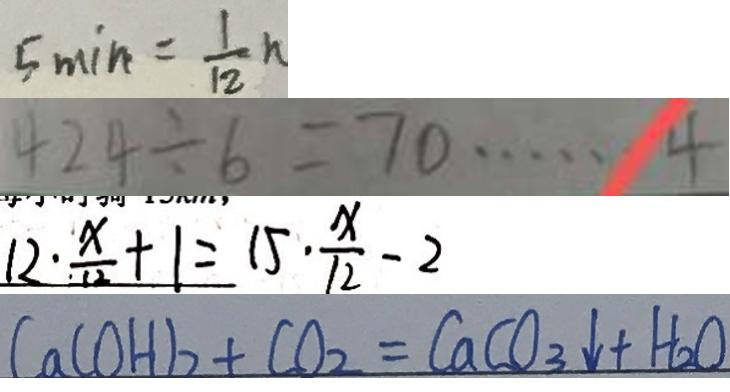<formula> <loc_0><loc_0><loc_500><loc_500>5 \min = \frac { 1 } { 1 2 } h 
 4 2 4 \div 6 = 7 0 \cdots 4 
 1 2 \cdot \frac { x } { 1 2 } + 1 = 1 5 \cdot \frac { x } { 1 2 } - 2 
 C a ( O H ) _ { 2 } + C O _ { 2 } = C a C O _ { 3 } \downarrow + H _ { 2 } O</formula> 